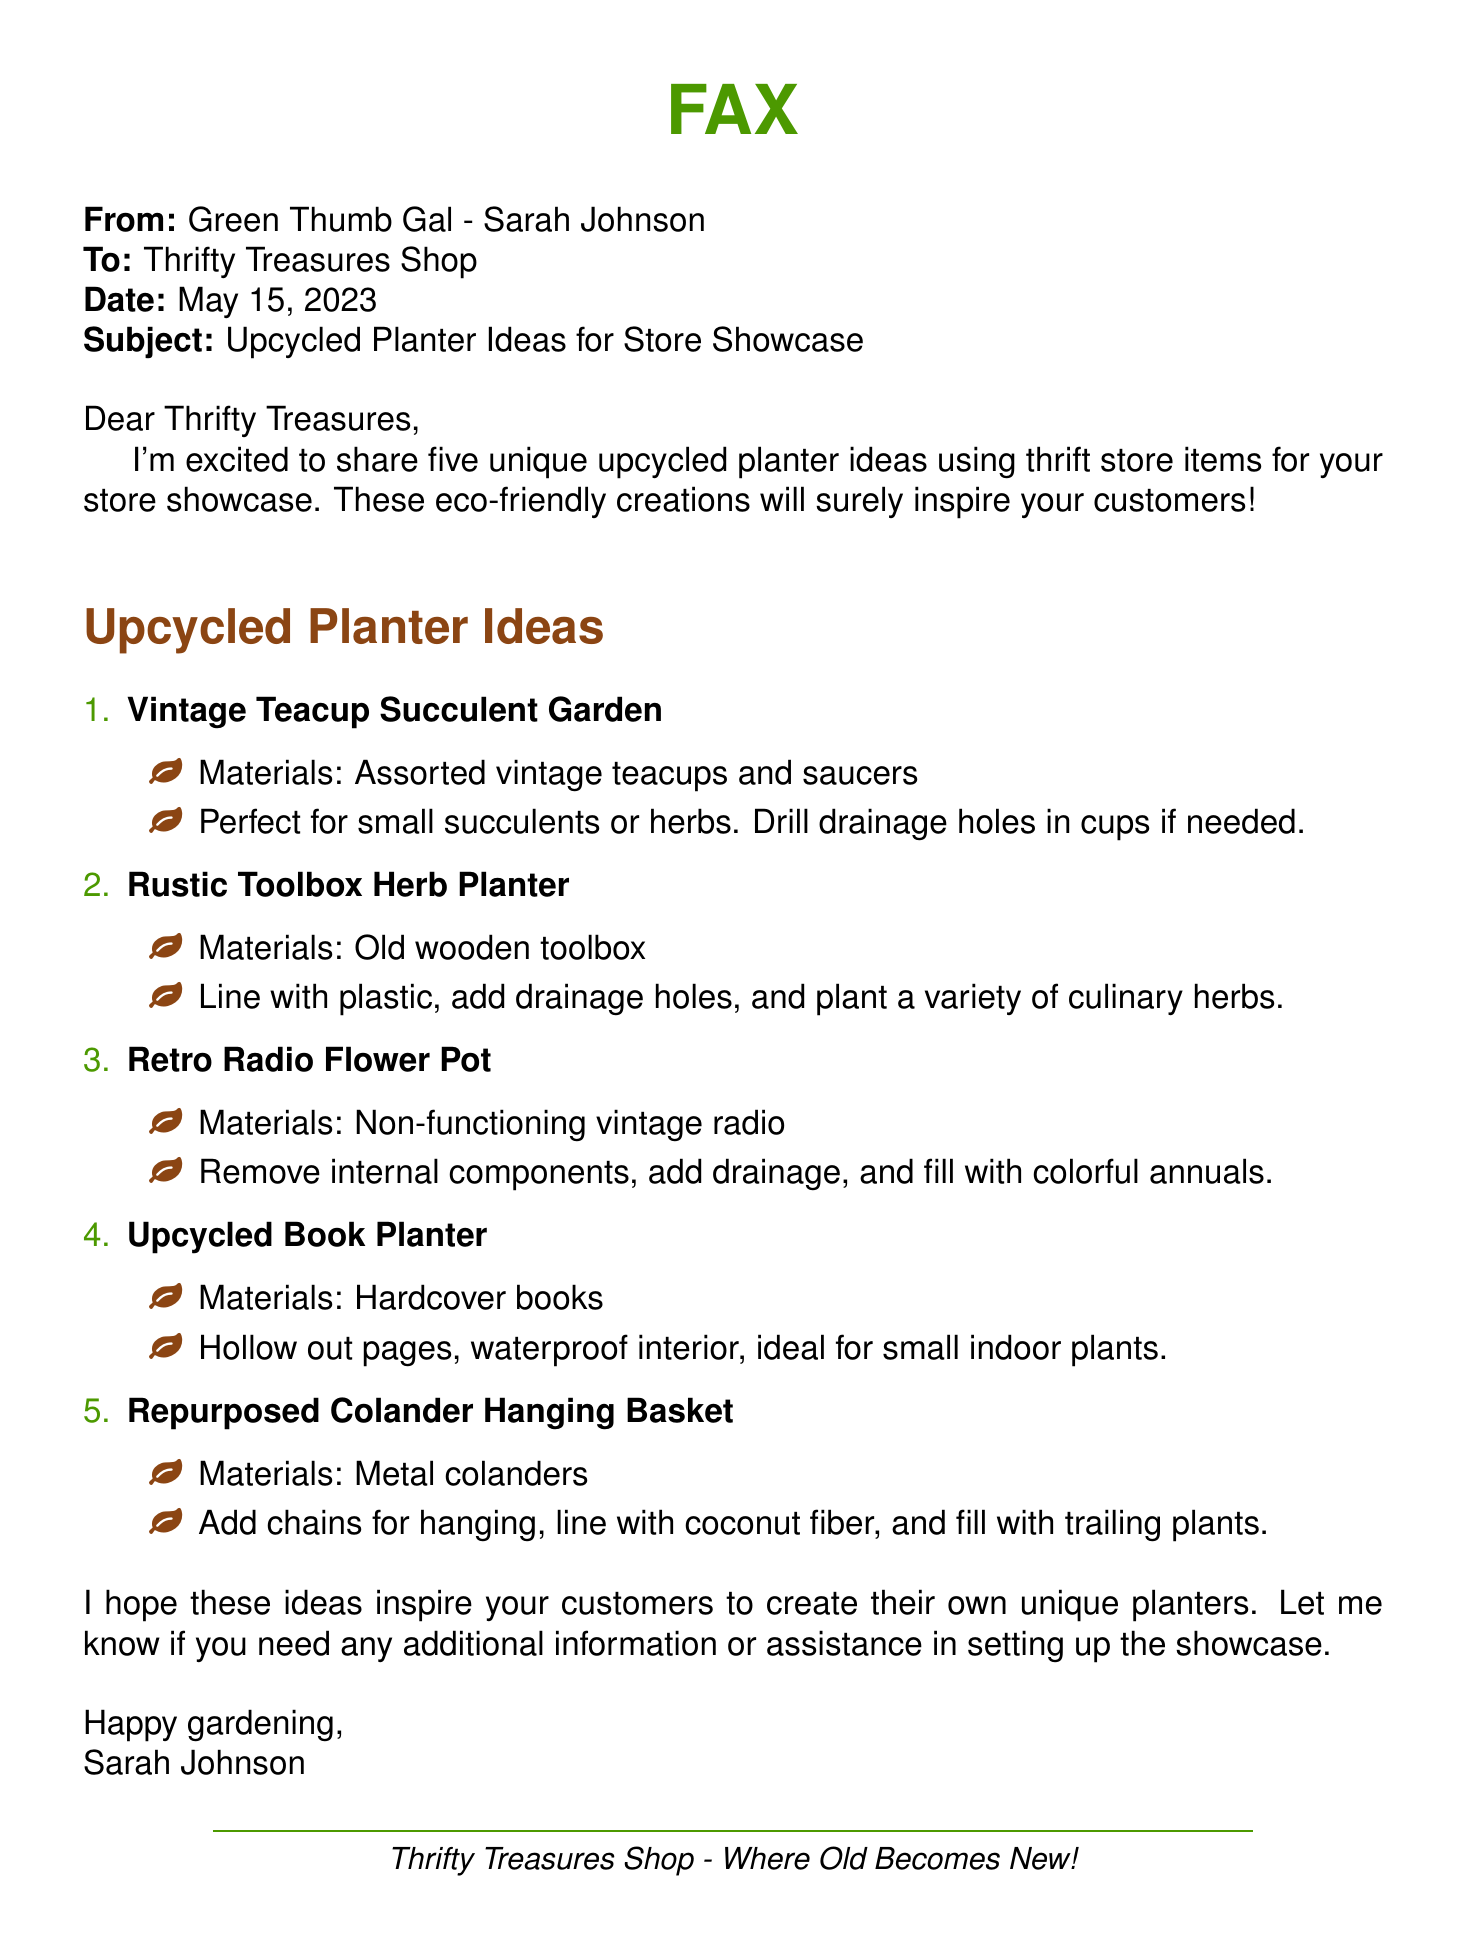What is the name of the sender? The sender is identified as Green Thumb Gal - Sarah Johnson in the document.
Answer: Sarah Johnson What is the date of the fax? The date is stated clearly in the document as May 15, 2023.
Answer: May 15, 2023 How many upcycled planter ideas are mentioned? The document lists a total of five upcycled planter ideas for the store showcase.
Answer: five What is the first planter idea mentioned? The first planter idea is outlined as the Vintage Teacup Succulent Garden in the list of ideas.
Answer: Vintage Teacup Succulent Garden What materials are used for the Retro Radio Flower Pot? The materials specified for this planter are non-functioning vintage radios.
Answer: Non-functioning vintage radio What can be used to hang the Repurposed Colander Hanging Basket? The document states that chains can be used for hanging the colander basket.
Answer: chains Which planter idea is designed for small indoor plants? The Upcycled Book Planter is specifically mentioned for small indoor plants.
Answer: Upcycled Book Planter What is suggested to line the Rustic Toolbox Herb Planter with? The document suggests lining the toolbox with plastic for the herb planter.
Answer: plastic What can be planted in the Vintage Teacup Succulent Garden? The suggested plants for this garden are small succulents or herbs.
Answer: small succulents or herbs 